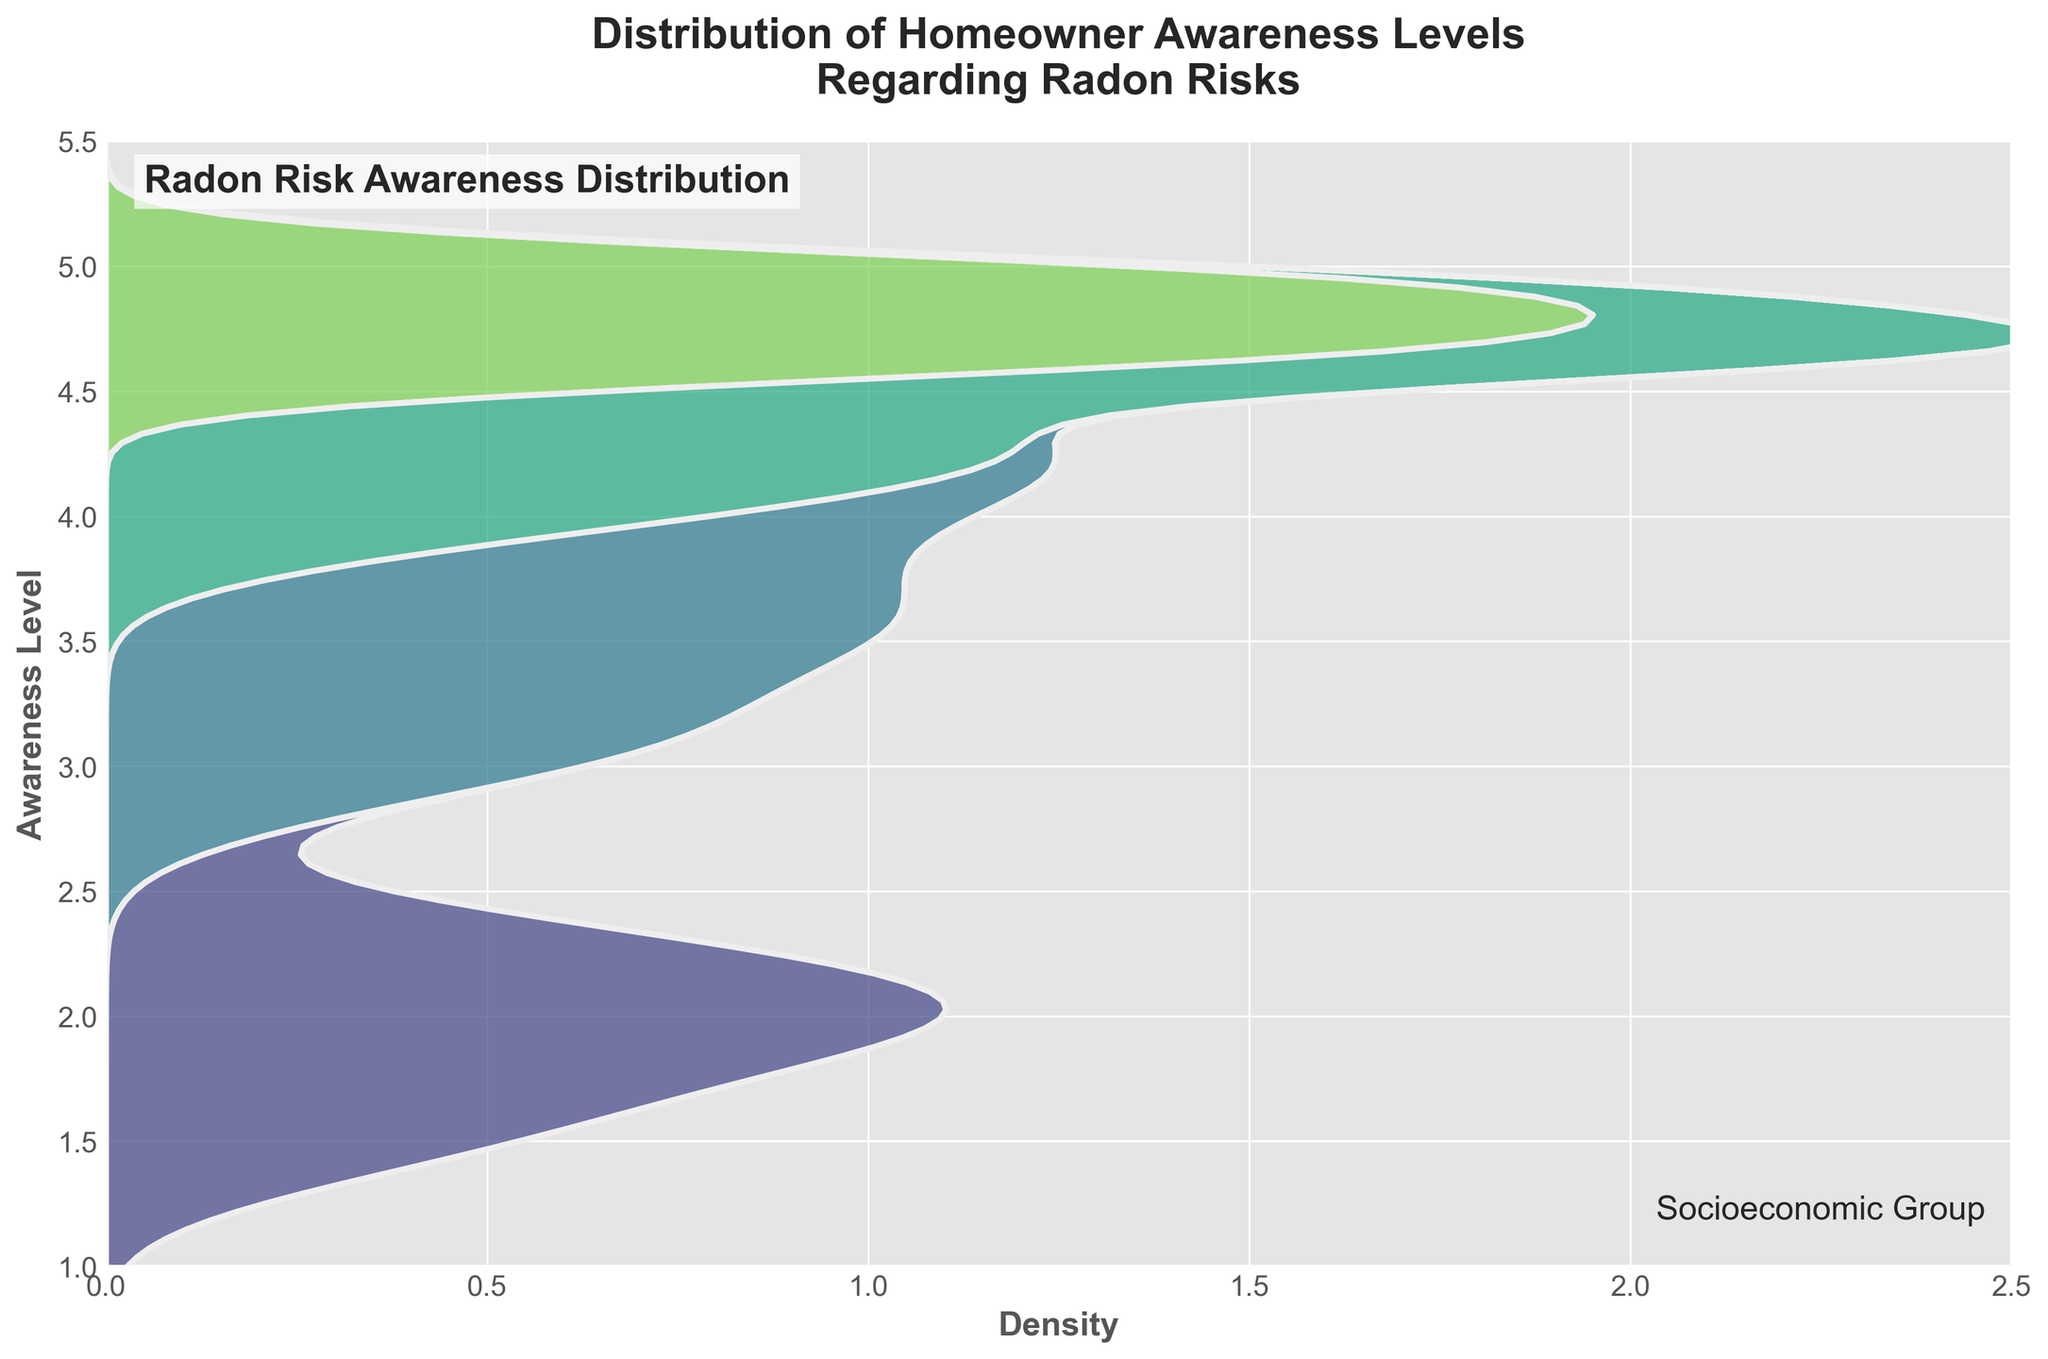What is the title of the figure? The title is the text at the top of the figure, which provides context for what the figure is showing. In this case, the title is in bold and large-sized font.
Answer: "Distribution of Homeowner Awareness Levels Regarding Radon Risks" Which socioeconomic group has the highest awareness level on average? The average awareness level for each socioeconomic group can be inferred by looking at the peaks or densest parts of the distribution for each group. The High_Income and Upper_Middle_Class groups have peaks at the highest awareness levels.
Answer: High_Income What is the awareness level range for the Low_Income group? The awareness level range for the Low_Income group spans from the lowest to the highest awareness level shown. The distribution for Low_Income starts at around 1.5 and goes up to around 2.3.
Answer: 1.5 to 2.3 How do the awareness levels of the Middle_Class group compare to the Low_Income group? Compare the peaks and the spread of the distributions for both groups. The Middle_Class group has a higher and wider spread of awareness levels compared to the Low_Income group, which suggests that Middle_Class homeowners generally have higher awareness levels on radon risks.
Answer: Middle_Class is higher Between Upper_Middle_Class and High_Income groups, which group's awareness level distribution shows more variance? Variance can be inferred by the spread of the curves. The Upper_Middle_Class group has peaks at 4.0 to 4.7 and High_Income has more peaks around 4.6 to 5.0, thus the Upper_Middle_Class appears to have slightly more spread in distribution.
Answer: Upper_Middle_Class What is the range of the x-axis, and what does it represent? The x-axis range can be determined by looking at the axis limits and tick marks. The x-axis represents the density of the data. From the figure, the x-axis spans from 0 to 2.5.
Answer: 0 to 2.5 Which awareness level appears to have the highest density for the High_Income group? The highest density within a group is indicated by the peak of its distribution curve. For the High_Income group, the peak is around an awareness level of 4.7 to 5.0.
Answer: 4.7 to 5.0 How does the awareness distribution for the Middle_Class group compare to that of the Upper_Middle_Class group? Compare the density peaks and spreads; the Middle_Class group has a peak around 3.5, whereas Upper_Middle_Class peaks around 4.2 to 4.5, indicating Upper_Middle_Class has higher awareness levels.
Answer: Upper_Middle_Class is higher Which socioeconomic group has the narrowest spread in awareness levels? The narrowest spread is indicated by the least variation in the density distribution. The Low_Income group shows the narrowest spread, as it ranges from 1.5 to 2.3.
Answer: Low_Income 